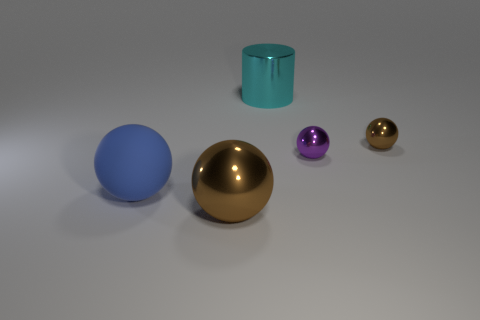Subtract 1 balls. How many balls are left? 3 Add 4 large shiny balls. How many objects exist? 9 Subtract all balls. How many objects are left? 1 Add 5 big blue balls. How many big blue balls are left? 6 Add 3 cyan shiny cylinders. How many cyan shiny cylinders exist? 4 Subtract 0 red cubes. How many objects are left? 5 Subtract all large blue things. Subtract all big brown metallic cylinders. How many objects are left? 4 